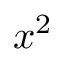Convert formula to latex. <formula><loc_0><loc_0><loc_500><loc_500>x ^ { 2 }</formula> 